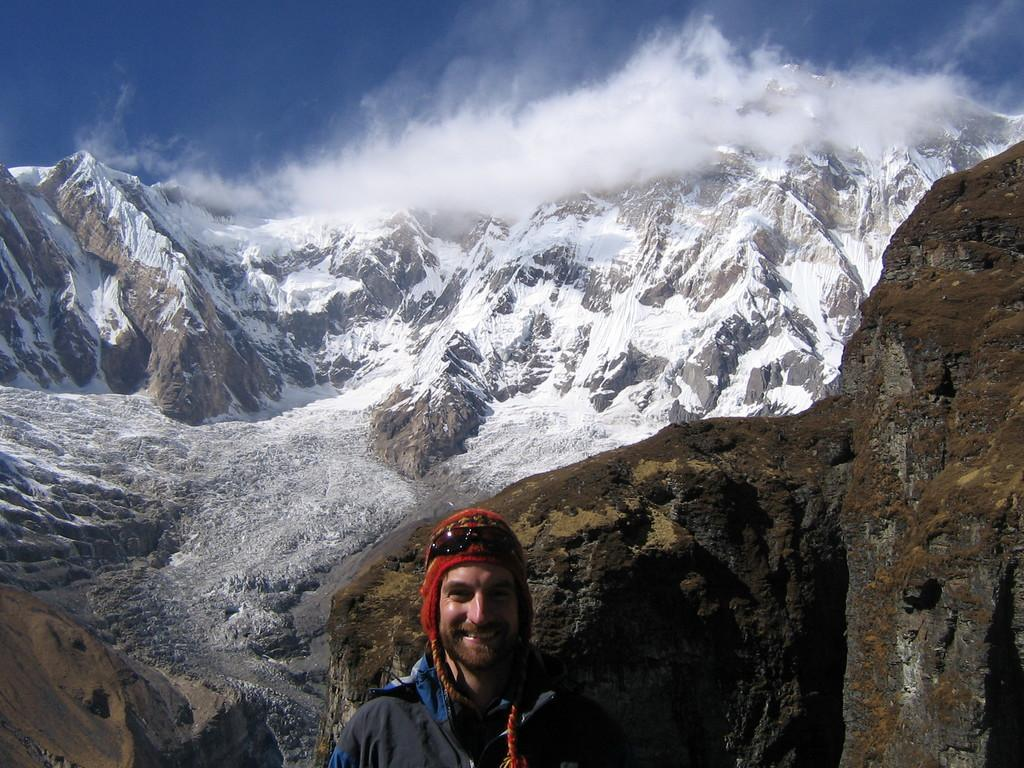What is the position of the man in the image? There is a man standing at the bottom of the image. What is the man's facial expression in the image? The man is smiling in the image. What type of headwear is the man wearing? The man is wearing a cap in the image. What can be seen in the background of the image? There are hills and the sky visible in the background of the image. What type of toothpaste is the man using in the image? There is no toothpaste present in the image; it features a man standing and smiling. 